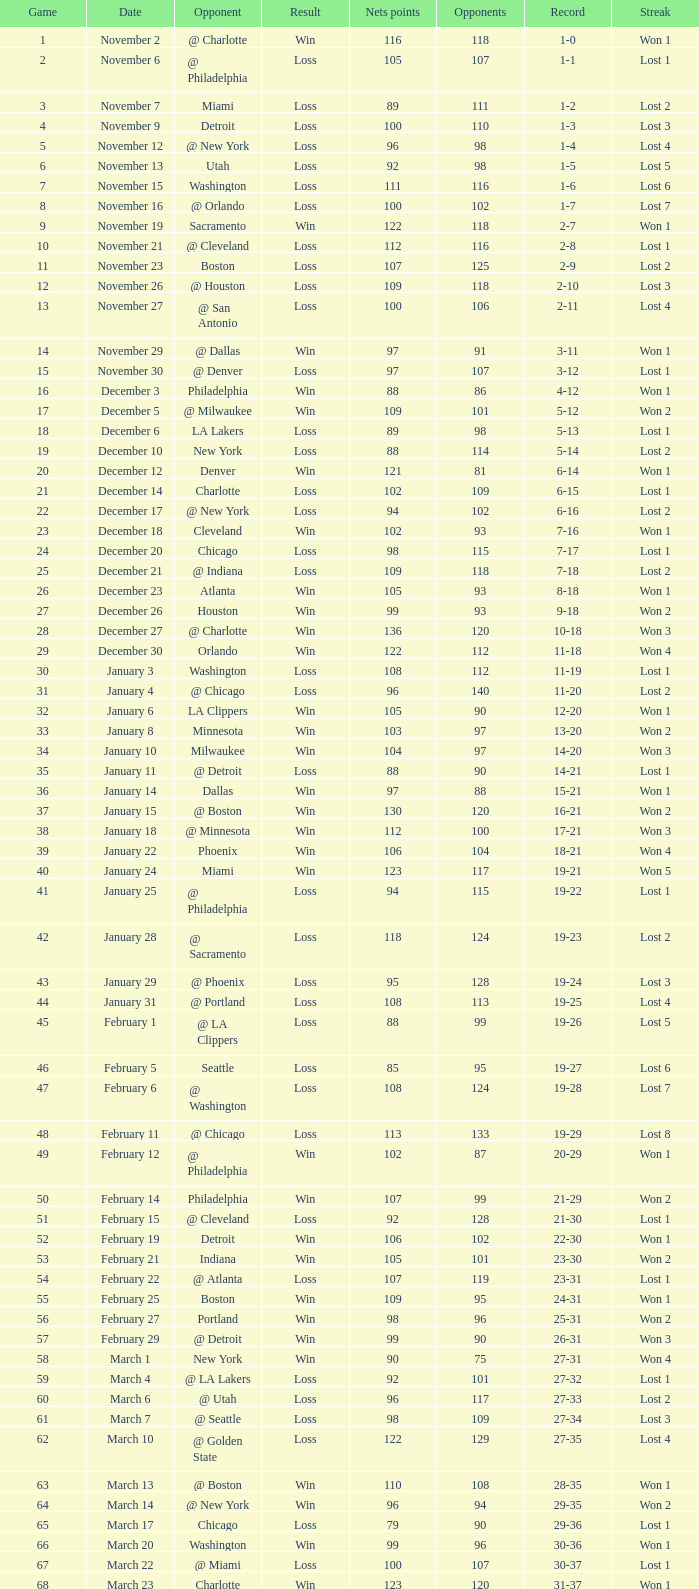What is the count of games featuring under 118 opponents and above 109 net points when playing against washington's adversary? 1.0. 